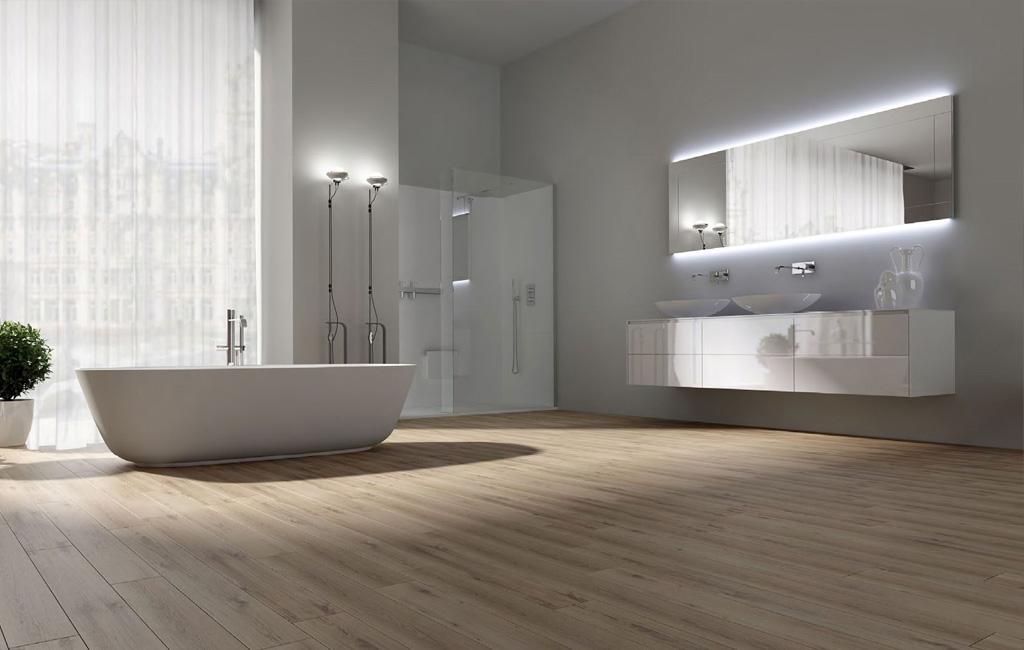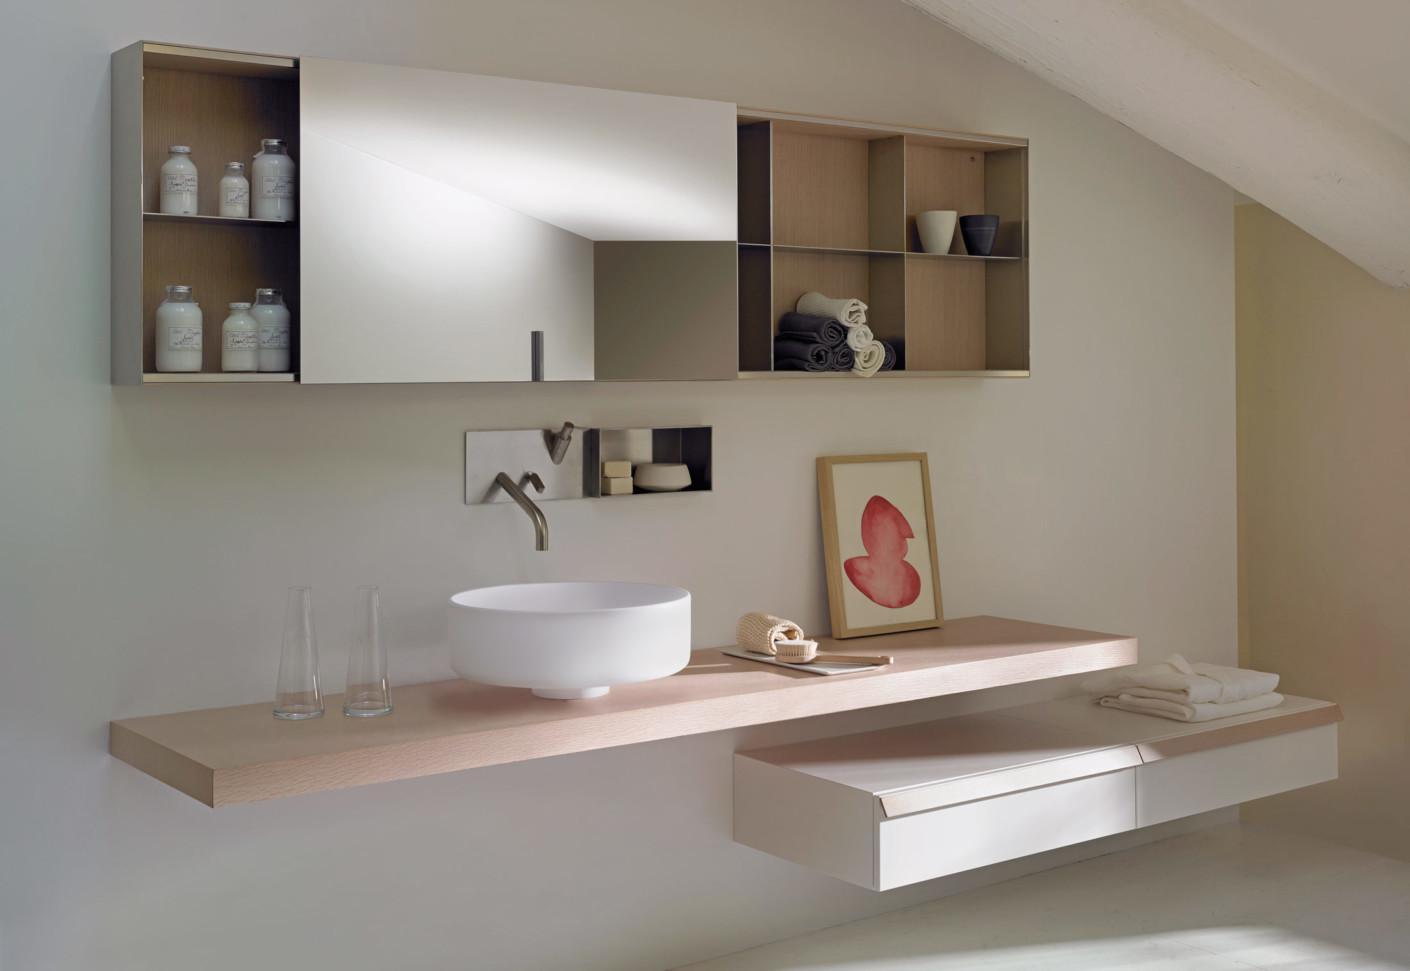The first image is the image on the left, the second image is the image on the right. Given the left and right images, does the statement "In one image, a wide box-like vanity attached to the wall has a white sink installed at one end, while the opposite end is open, showing towel storage." hold true? Answer yes or no. No. The first image is the image on the left, the second image is the image on the right. For the images displayed, is the sentence "An image shows a wall-mounted beige vanity with opened shelf section containing stacks of white towels." factually correct? Answer yes or no. No. 